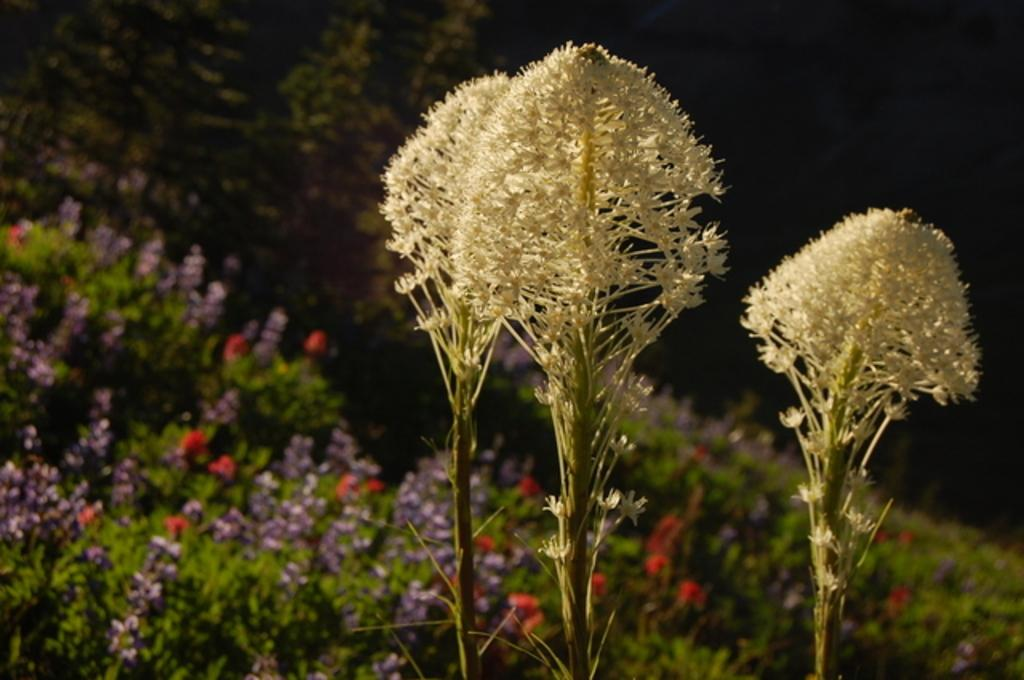What type of plants are visible in the image? There are plants with flowers in the image. What can be observed about the background of the image? The background of the image is dark. Can you see a river flowing through the image? There is no river visible in the image; it features plants with flowers against a dark background. 